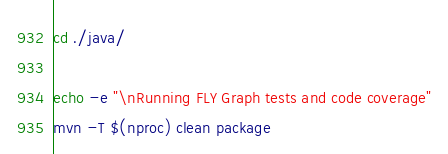Convert code to text. <code><loc_0><loc_0><loc_500><loc_500><_Bash_>cd ./java/

echo -e "\nRunning FLY Graph tests and code coverage"
mvn -T $(nproc) clean package
</code> 